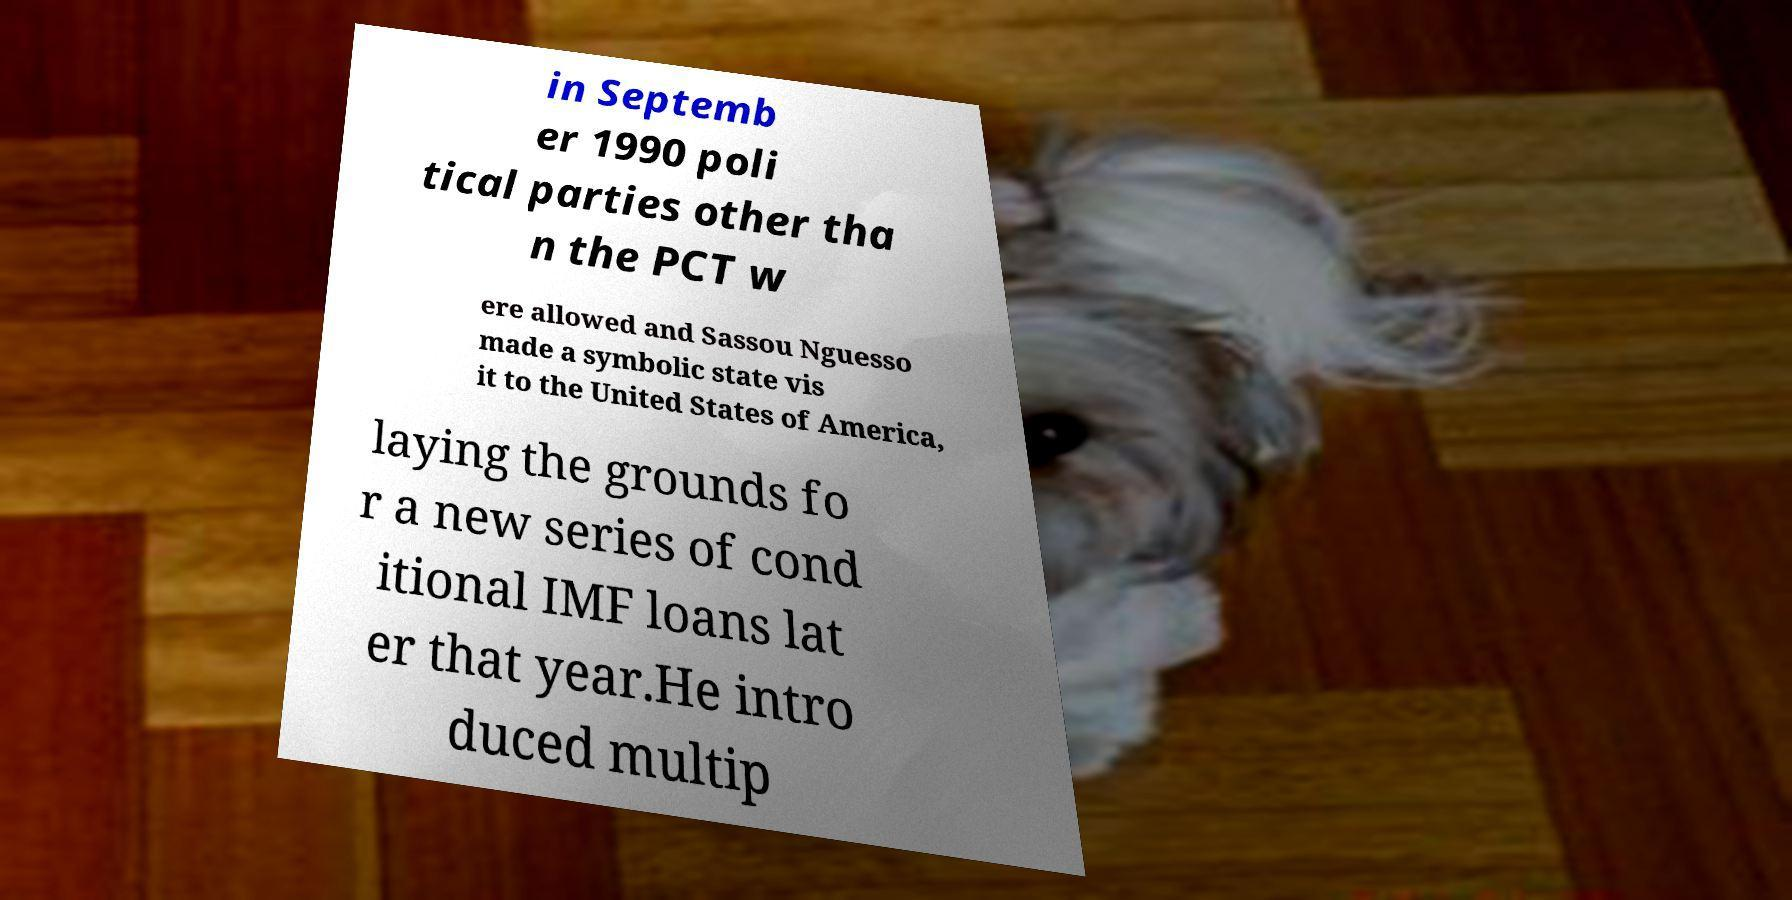Could you extract and type out the text from this image? in Septemb er 1990 poli tical parties other tha n the PCT w ere allowed and Sassou Nguesso made a symbolic state vis it to the United States of America, laying the grounds fo r a new series of cond itional IMF loans lat er that year.He intro duced multip 